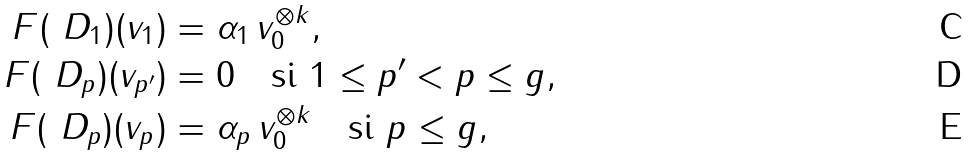<formula> <loc_0><loc_0><loc_500><loc_500>\ F ( \ D _ { 1 } ) ( v _ { 1 } ) & = \alpha _ { 1 } \, v _ { 0 } ^ { \otimes k } , \\ \ F ( \ D _ { p } ) ( v _ { p ^ { \prime } } ) & = 0 \quad \text {si $1\leq p^{\prime}<p\leq g$} , \\ \ F ( \ D _ { p } ) ( v _ { p } ) & = \alpha _ { p } \, v _ { 0 } ^ { \otimes k } \quad \text {si $p\leq g$} ,</formula> 